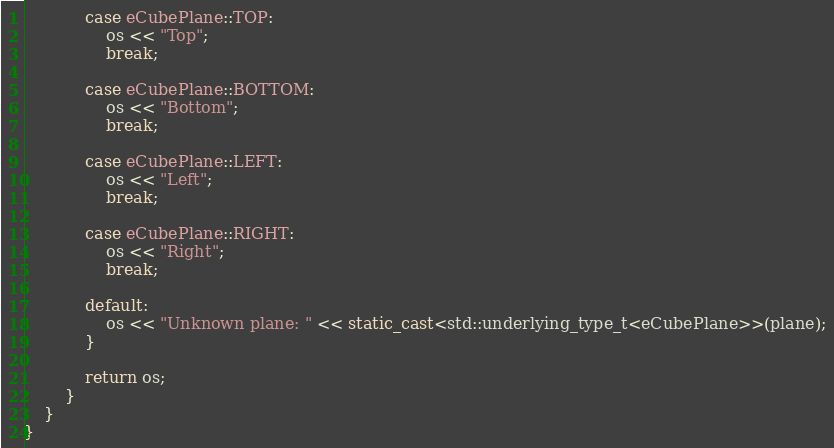<code> <loc_0><loc_0><loc_500><loc_500><_C++_>			case eCubePlane::TOP: 
				os << "Top"; 
				break;

			case eCubePlane::BOTTOM:
				os << "Bottom"; 
				break;

			case eCubePlane::LEFT:
				os << "Left"; 
				break;

			case eCubePlane::RIGHT: 
				os << "Right"; 
				break;

			default:
				os << "Unknown plane: " << static_cast<std::underlying_type_t<eCubePlane>>(plane);
			}

			return os;
		}
	}
}</code> 